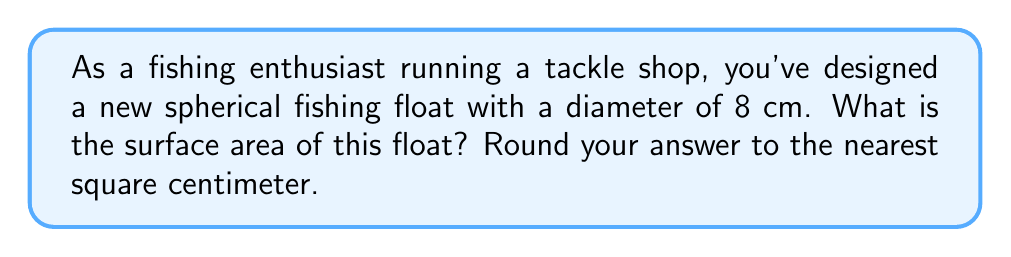Can you solve this math problem? To solve this problem, let's follow these steps:

1) The formula for the surface area of a sphere is:
   $$A = 4\pi r^2$$
   where $A$ is the surface area and $r$ is the radius of the sphere.

2) We're given the diameter of the float, which is 8 cm. The radius is half of the diameter:
   $$r = \frac{8}{2} = 4 \text{ cm}$$

3) Now we can substitute this value into our formula:
   $$A = 4\pi (4\text{ cm})^2$$

4) Simplify the expression inside the parentheses:
   $$A = 4\pi (16\text{ cm}^2)$$

5) Multiply:
   $$A = 64\pi \text{ cm}^2$$

6) Use 3.14159 as an approximation for $\pi$:
   $$A \approx 64 * 3.14159 \text{ cm}^2 = 201.06176 \text{ cm}^2$$

7) Rounding to the nearest square centimeter:
   $$A \approx 201 \text{ cm}^2$$

[asy]
import geometry;

size(100);
draw(circle((0,0),4));
draw((0,0)--(4,0),dashed);
label("4 cm",(-1,1.5),NE);
label("8 cm",(-4,0),W);
</asy]
Answer: 201 cm² 